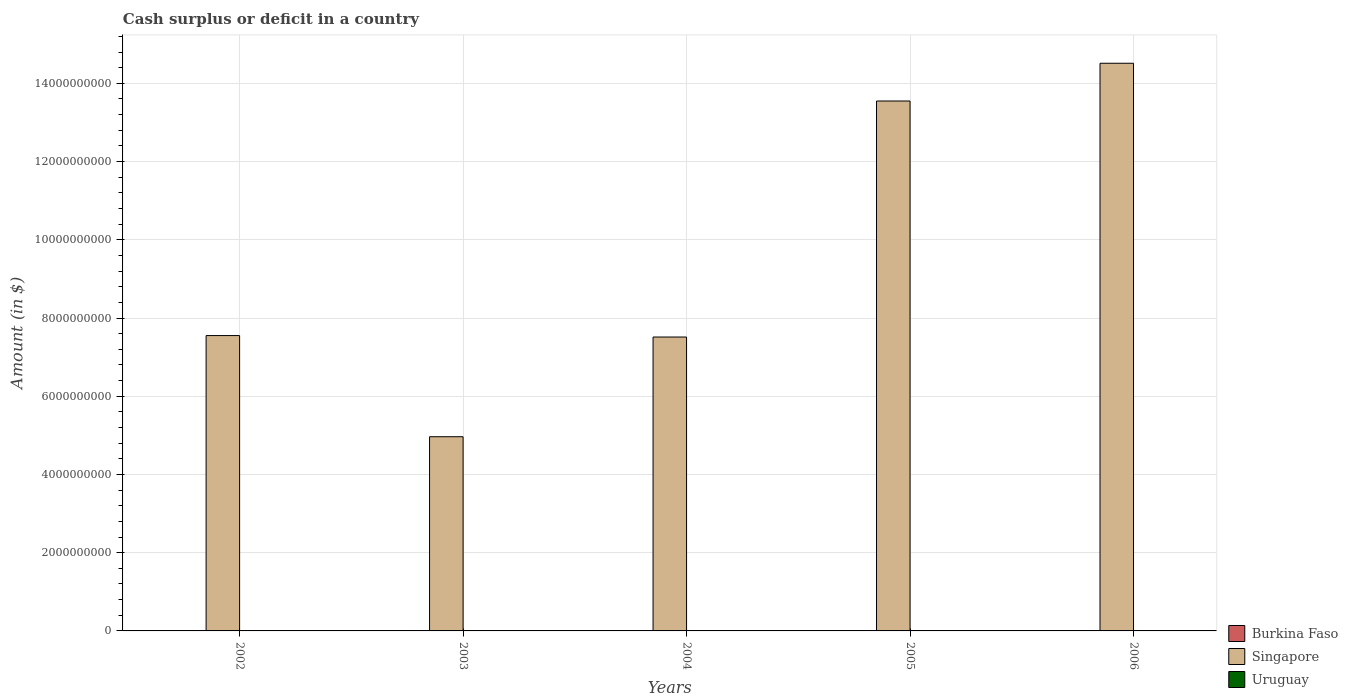How many different coloured bars are there?
Offer a very short reply. 1. Are the number of bars on each tick of the X-axis equal?
Provide a succinct answer. Yes. How many bars are there on the 5th tick from the left?
Make the answer very short. 1. What is the label of the 3rd group of bars from the left?
Your answer should be compact. 2004. What is the amount of cash surplus or deficit in Uruguay in 2002?
Offer a terse response. 0. Across all years, what is the maximum amount of cash surplus or deficit in Singapore?
Offer a terse response. 1.45e+1. Across all years, what is the minimum amount of cash surplus or deficit in Singapore?
Ensure brevity in your answer.  4.96e+09. In which year was the amount of cash surplus or deficit in Singapore maximum?
Provide a short and direct response. 2006. What is the difference between the amount of cash surplus or deficit in Singapore in 2003 and that in 2004?
Keep it short and to the point. -2.55e+09. In how many years, is the amount of cash surplus or deficit in Uruguay greater than 1600000000 $?
Give a very brief answer. 0. What is the ratio of the amount of cash surplus or deficit in Singapore in 2004 to that in 2005?
Keep it short and to the point. 0.55. What is the difference between the highest and the second highest amount of cash surplus or deficit in Singapore?
Ensure brevity in your answer.  9.65e+08. In how many years, is the amount of cash surplus or deficit in Singapore greater than the average amount of cash surplus or deficit in Singapore taken over all years?
Make the answer very short. 2. Are the values on the major ticks of Y-axis written in scientific E-notation?
Your answer should be very brief. No. Does the graph contain grids?
Offer a very short reply. Yes. How many legend labels are there?
Make the answer very short. 3. How are the legend labels stacked?
Offer a very short reply. Vertical. What is the title of the graph?
Keep it short and to the point. Cash surplus or deficit in a country. Does "Aruba" appear as one of the legend labels in the graph?
Keep it short and to the point. No. What is the label or title of the X-axis?
Offer a very short reply. Years. What is the label or title of the Y-axis?
Keep it short and to the point. Amount (in $). What is the Amount (in $) in Singapore in 2002?
Your response must be concise. 7.55e+09. What is the Amount (in $) in Singapore in 2003?
Offer a terse response. 4.96e+09. What is the Amount (in $) in Burkina Faso in 2004?
Your answer should be very brief. 0. What is the Amount (in $) of Singapore in 2004?
Provide a short and direct response. 7.51e+09. What is the Amount (in $) in Singapore in 2005?
Offer a very short reply. 1.35e+1. What is the Amount (in $) of Uruguay in 2005?
Provide a succinct answer. 0. What is the Amount (in $) of Burkina Faso in 2006?
Your answer should be very brief. 0. What is the Amount (in $) in Singapore in 2006?
Provide a succinct answer. 1.45e+1. Across all years, what is the maximum Amount (in $) in Singapore?
Give a very brief answer. 1.45e+1. Across all years, what is the minimum Amount (in $) in Singapore?
Your response must be concise. 4.96e+09. What is the total Amount (in $) in Burkina Faso in the graph?
Your answer should be compact. 0. What is the total Amount (in $) in Singapore in the graph?
Your answer should be very brief. 4.81e+1. What is the total Amount (in $) in Uruguay in the graph?
Your answer should be compact. 0. What is the difference between the Amount (in $) of Singapore in 2002 and that in 2003?
Give a very brief answer. 2.59e+09. What is the difference between the Amount (in $) in Singapore in 2002 and that in 2004?
Ensure brevity in your answer.  3.70e+07. What is the difference between the Amount (in $) of Singapore in 2002 and that in 2005?
Offer a very short reply. -6.00e+09. What is the difference between the Amount (in $) in Singapore in 2002 and that in 2006?
Your answer should be compact. -6.96e+09. What is the difference between the Amount (in $) of Singapore in 2003 and that in 2004?
Offer a very short reply. -2.55e+09. What is the difference between the Amount (in $) in Singapore in 2003 and that in 2005?
Offer a terse response. -8.58e+09. What is the difference between the Amount (in $) of Singapore in 2003 and that in 2006?
Offer a terse response. -9.55e+09. What is the difference between the Amount (in $) in Singapore in 2004 and that in 2005?
Your response must be concise. -6.03e+09. What is the difference between the Amount (in $) in Singapore in 2004 and that in 2006?
Your answer should be very brief. -7.00e+09. What is the difference between the Amount (in $) of Singapore in 2005 and that in 2006?
Keep it short and to the point. -9.65e+08. What is the average Amount (in $) of Burkina Faso per year?
Offer a terse response. 0. What is the average Amount (in $) of Singapore per year?
Keep it short and to the point. 9.62e+09. What is the ratio of the Amount (in $) of Singapore in 2002 to that in 2003?
Provide a short and direct response. 1.52. What is the ratio of the Amount (in $) in Singapore in 2002 to that in 2005?
Your answer should be compact. 0.56. What is the ratio of the Amount (in $) of Singapore in 2002 to that in 2006?
Your answer should be compact. 0.52. What is the ratio of the Amount (in $) in Singapore in 2003 to that in 2004?
Provide a short and direct response. 0.66. What is the ratio of the Amount (in $) in Singapore in 2003 to that in 2005?
Offer a terse response. 0.37. What is the ratio of the Amount (in $) in Singapore in 2003 to that in 2006?
Your response must be concise. 0.34. What is the ratio of the Amount (in $) of Singapore in 2004 to that in 2005?
Your response must be concise. 0.55. What is the ratio of the Amount (in $) of Singapore in 2004 to that in 2006?
Offer a terse response. 0.52. What is the ratio of the Amount (in $) in Singapore in 2005 to that in 2006?
Provide a succinct answer. 0.93. What is the difference between the highest and the second highest Amount (in $) in Singapore?
Provide a short and direct response. 9.65e+08. What is the difference between the highest and the lowest Amount (in $) in Singapore?
Provide a succinct answer. 9.55e+09. 